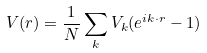<formula> <loc_0><loc_0><loc_500><loc_500>V ( { r } ) = \frac { 1 } { N } \sum _ { k } V _ { k } ( e ^ { i { k } \cdot { r } } - 1 )</formula> 